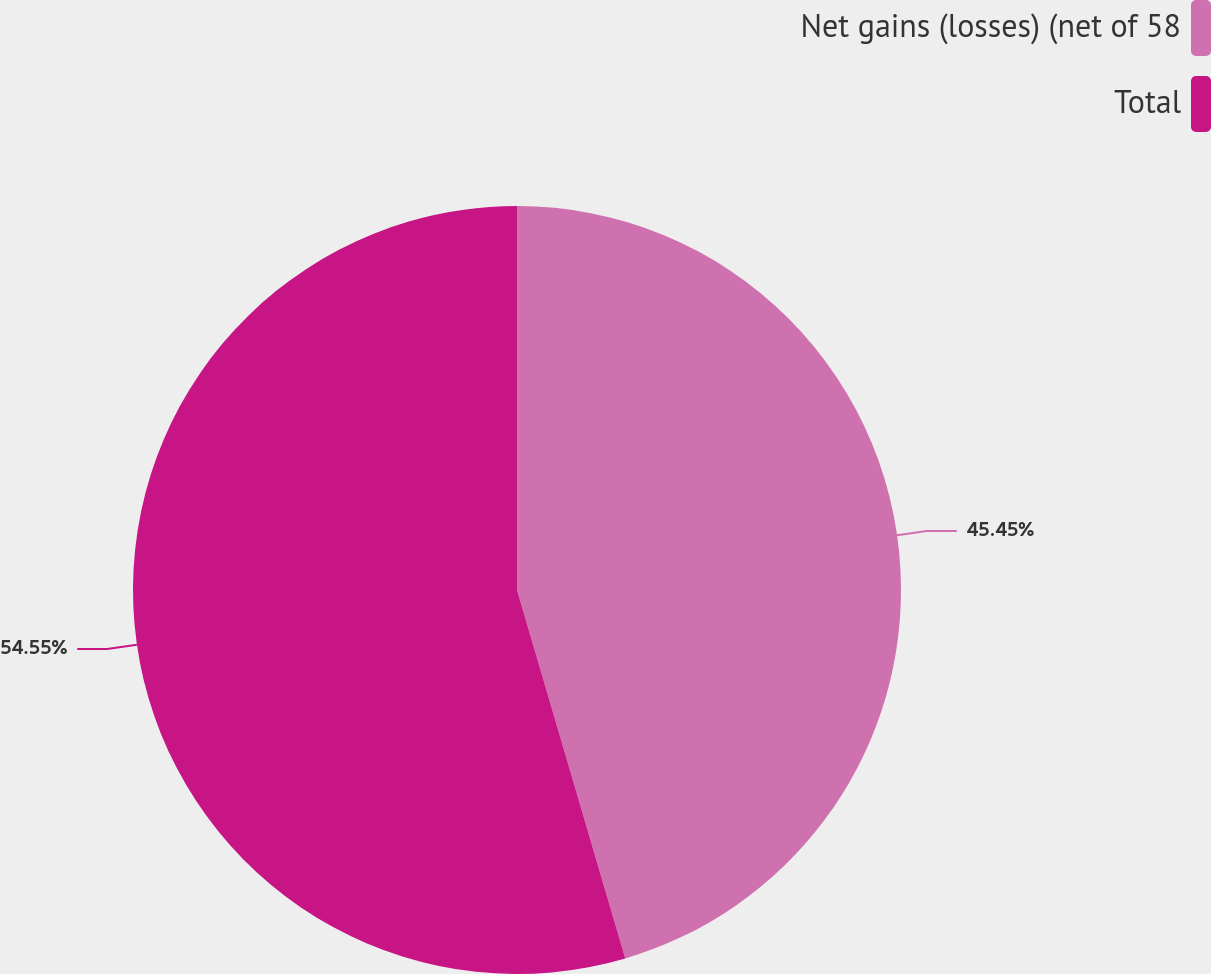Convert chart. <chart><loc_0><loc_0><loc_500><loc_500><pie_chart><fcel>Net gains (losses) (net of 58<fcel>Total<nl><fcel>45.45%<fcel>54.55%<nl></chart> 